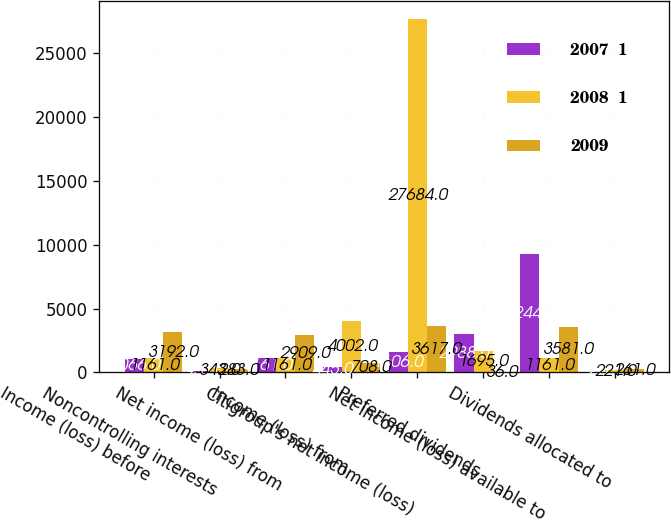Convert chart to OTSL. <chart><loc_0><loc_0><loc_500><loc_500><stacked_bar_chart><ecel><fcel>Income (loss) before<fcel>Noncontrolling interests<fcel>Net income (loss) from<fcel>Income (loss) from<fcel>Citigroup's net income (loss)<fcel>Preferred dividends<fcel>Net income (loss) available to<fcel>Dividends allocated to<nl><fcel>2007  1<fcel>1066<fcel>95<fcel>1161<fcel>445<fcel>1606<fcel>2988<fcel>9244<fcel>2<nl><fcel>2008  1<fcel>1161<fcel>343<fcel>1161<fcel>4002<fcel>27684<fcel>1695<fcel>1161<fcel>221<nl><fcel>2009<fcel>3192<fcel>283<fcel>2909<fcel>708<fcel>3617<fcel>36<fcel>3581<fcel>261<nl></chart> 